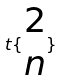<formula> <loc_0><loc_0><loc_500><loc_500>t \{ \begin{matrix} 2 \\ n \end{matrix} \}</formula> 